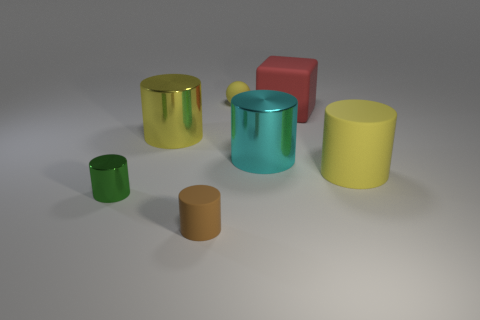Is there any other thing that has the same size as the red rubber thing?
Your answer should be compact. Yes. Are there fewer big cyan things to the left of the large cyan shiny cylinder than large green matte balls?
Make the answer very short. No. Is there any other thing that has the same shape as the brown object?
Offer a very short reply. Yes. There is a brown rubber object in front of the yellow matte cylinder; what shape is it?
Ensure brevity in your answer.  Cylinder. There is a matte object in front of the yellow cylinder on the right side of the big yellow cylinder to the left of the big red matte cube; what shape is it?
Ensure brevity in your answer.  Cylinder. How many things are either big blue matte objects or tiny brown matte cylinders?
Your answer should be very brief. 1. There is a yellow thing that is in front of the cyan metal cylinder; is its shape the same as the small rubber object in front of the green metal object?
Offer a very short reply. Yes. How many shiny objects are both on the right side of the yellow metal object and in front of the big yellow matte thing?
Your answer should be compact. 0. What number of other things are the same size as the yellow rubber cylinder?
Make the answer very short. 3. There is a yellow thing that is both in front of the red matte object and behind the large matte cylinder; what is its material?
Offer a very short reply. Metal. 